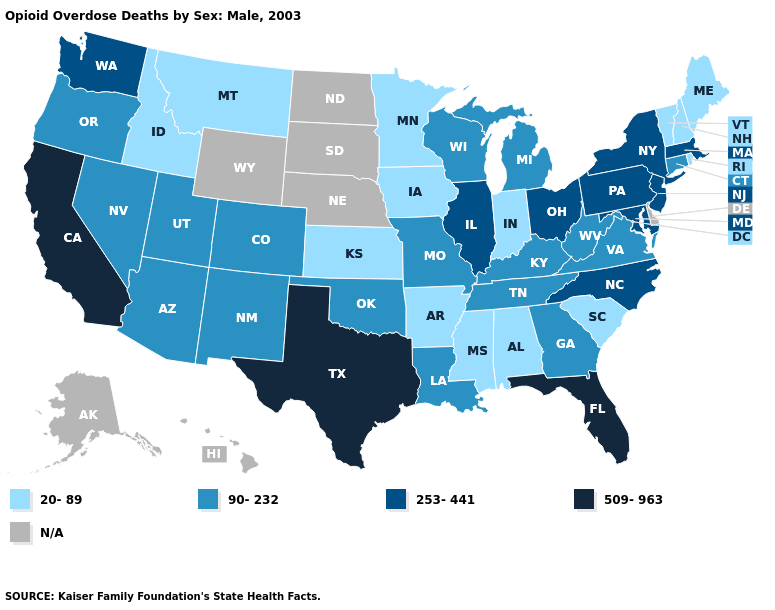Which states have the lowest value in the South?
Write a very short answer. Alabama, Arkansas, Mississippi, South Carolina. Among the states that border Nevada , which have the highest value?
Quick response, please. California. What is the highest value in the USA?
Answer briefly. 509-963. Name the states that have a value in the range 20-89?
Be succinct. Alabama, Arkansas, Idaho, Indiana, Iowa, Kansas, Maine, Minnesota, Mississippi, Montana, New Hampshire, Rhode Island, South Carolina, Vermont. Does Maryland have the lowest value in the USA?
Quick response, please. No. What is the highest value in states that border Virginia?
Be succinct. 253-441. What is the highest value in the USA?
Give a very brief answer. 509-963. Does Ohio have the lowest value in the USA?
Concise answer only. No. Among the states that border Texas , does Arkansas have the lowest value?
Quick response, please. Yes. What is the highest value in the MidWest ?
Quick response, please. 253-441. What is the highest value in the South ?
Quick response, please. 509-963. How many symbols are there in the legend?
Be succinct. 5. 